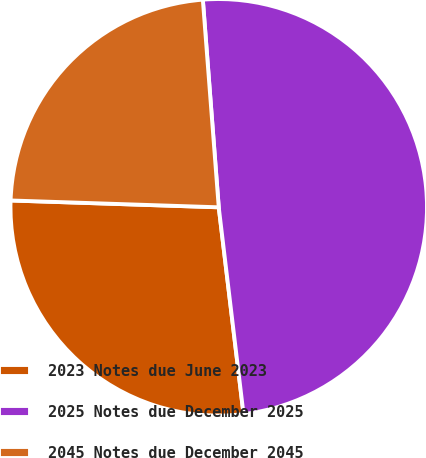Convert chart to OTSL. <chart><loc_0><loc_0><loc_500><loc_500><pie_chart><fcel>2023 Notes due June 2023<fcel>2025 Notes due December 2025<fcel>2045 Notes due December 2045<nl><fcel>27.42%<fcel>49.32%<fcel>23.26%<nl></chart> 